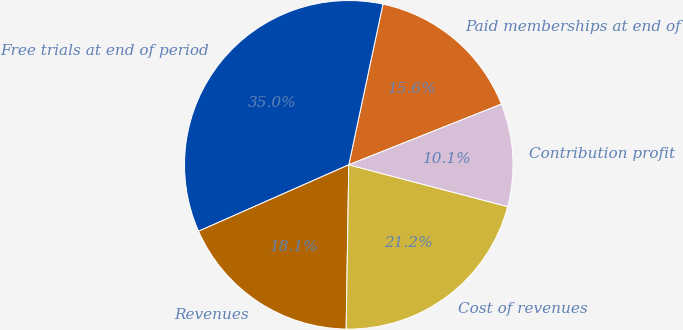Convert chart to OTSL. <chart><loc_0><loc_0><loc_500><loc_500><pie_chart><fcel>Paid memberships at end of<fcel>Free trials at end of period<fcel>Revenues<fcel>Cost of revenues<fcel>Contribution profit<nl><fcel>15.64%<fcel>34.96%<fcel>18.12%<fcel>21.16%<fcel>10.12%<nl></chart> 